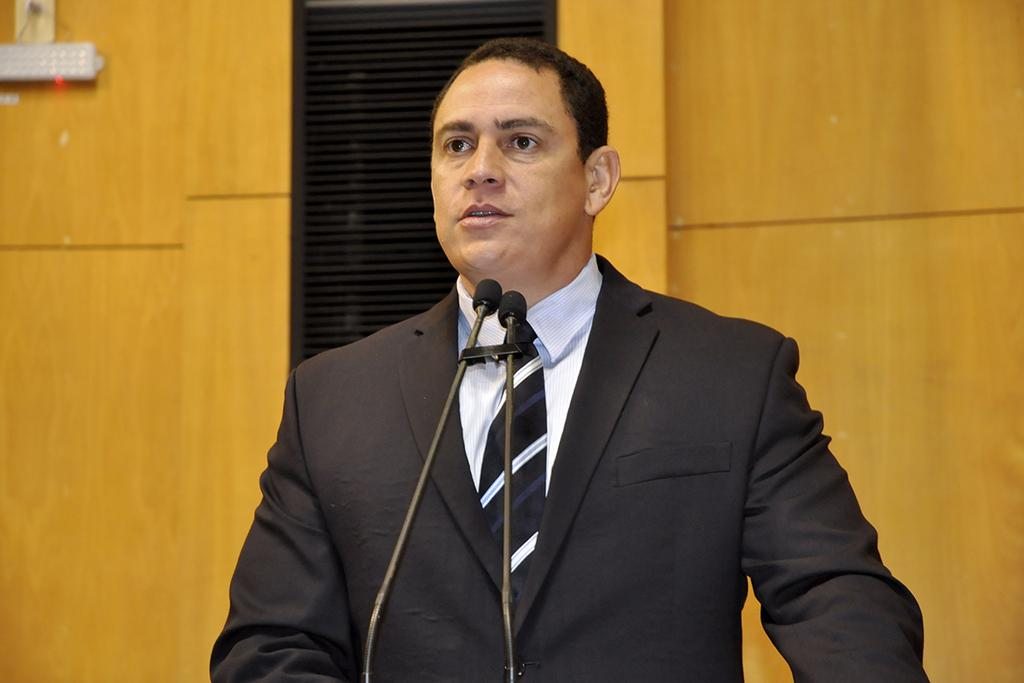Who is present in the image? There is a person in the image. What is the person wearing? The person is wearing a suit. What can be seen behind the person? The person is standing in front of microphones. What type of bomb can be seen in the image? There is no bomb present in the image. What news is being reported by the person in the image? The image does not provide any information about the news being reported, as it only shows a person standing in front of microphones. 